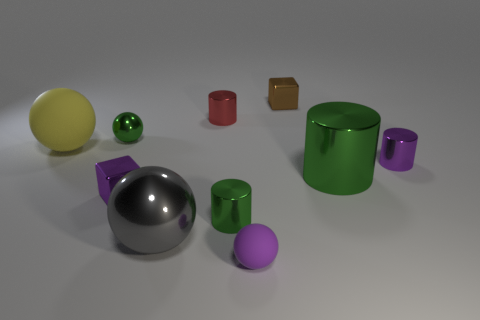Subtract all blocks. How many objects are left? 8 Add 1 big blue cubes. How many big blue cubes exist? 1 Subtract 0 green blocks. How many objects are left? 10 Subtract all small things. Subtract all purple blocks. How many objects are left? 2 Add 4 tiny green shiny spheres. How many tiny green shiny spheres are left? 5 